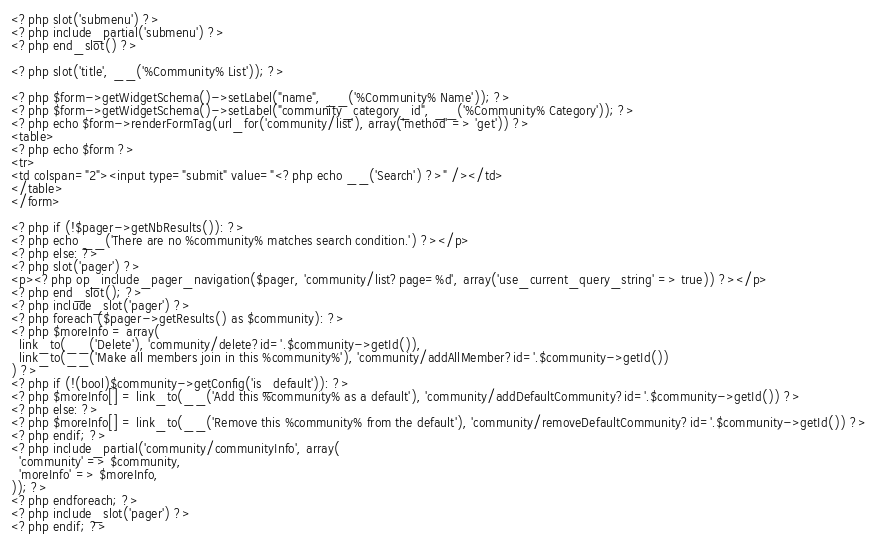<code> <loc_0><loc_0><loc_500><loc_500><_PHP_><?php slot('submenu') ?>
<?php include_partial('submenu') ?>
<?php end_slot() ?>

<?php slot('title', __('%Community% List')); ?>

<?php $form->getWidgetSchema()->setLabel("name", __('%Community% Name')); ?>
<?php $form->getWidgetSchema()->setLabel("community_category_id", __('%Community% Category')); ?>
<?php echo $form->renderFormTag(url_for('community/list'), array('method' => 'get')) ?>
<table>
<?php echo $form ?>
<tr>
<td colspan="2"><input type="submit" value="<?php echo __('Search') ?>" /></td>
</table>
</form>

<?php if (!$pager->getNbResults()): ?>
<?php echo __('There are no %community% matches search condition.') ?></p>
<?php else: ?>
<?php slot('pager') ?>
<p><?php op_include_pager_navigation($pager, 'community/list?page=%d', array('use_current_query_string' => true)) ?></p>
<?php end_slot(); ?>
<?php include_slot('pager') ?>
<?php foreach ($pager->getResults() as $community): ?>
<?php $moreInfo = array(
  link_to(__('Delete'), 'community/delete?id='.$community->getId()),
  link_to(__('Make all members join in this %community%'), 'community/addAllMember?id='.$community->getId())
) ?>
<?php if (!(bool)$community->getConfig('is_default')): ?>
<?php $moreInfo[] = link_to(__('Add this %community% as a default'), 'community/addDefaultCommunity?id='.$community->getId()) ?>
<?php else: ?>
<?php $moreInfo[] = link_to(__('Remove this %community% from the default'), 'community/removeDefaultCommunity?id='.$community->getId()) ?>
<?php endif; ?>
<?php include_partial('community/communityInfo', array(
  'community' => $community, 
  'moreInfo' => $moreInfo,
)); ?>
<?php endforeach; ?>
<?php include_slot('pager') ?>
<?php endif; ?>
</code> 